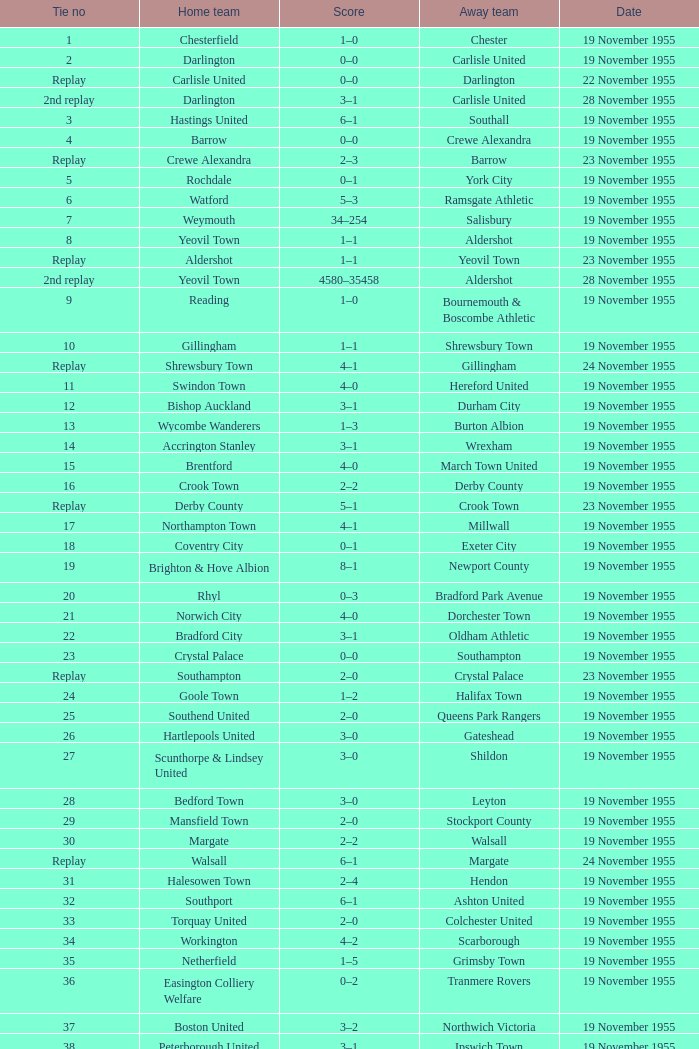What is the away team with a 5 tie no? York City. 